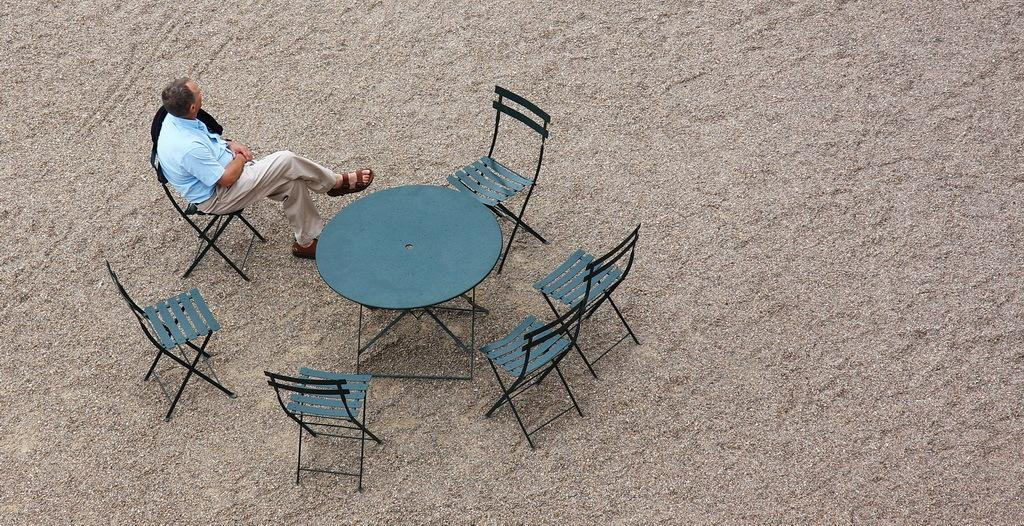Who is present in the image? There is a person in the image. What is the person wearing? The person is wearing a blue shirt. What is the person doing in the image? The person is sitting on a chair. How many chairs are visible in the image? There are additional chairs in the image. What is placed on the ground in the image? There is a table placed on the ground in the image. What type of theory is being discussed by the person in the image? There is no indication in the image that the person is discussing any theory. 